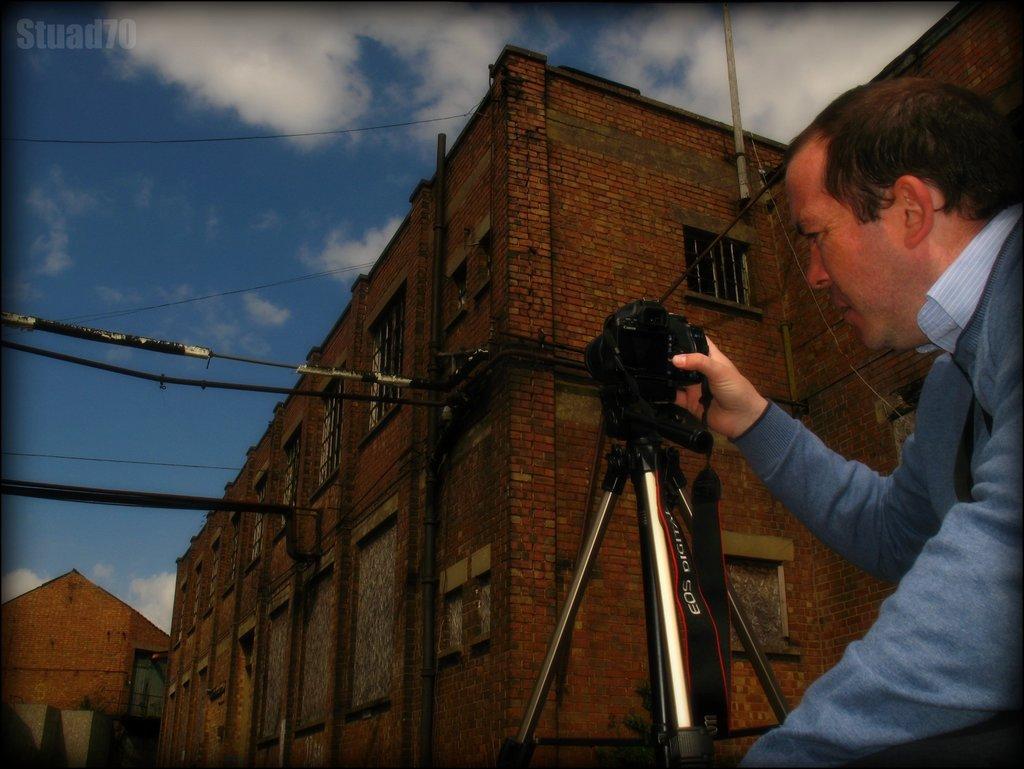Describe this image in one or two sentences. As we can see in the image there is a sky, clouds, building and a man holding camera. 